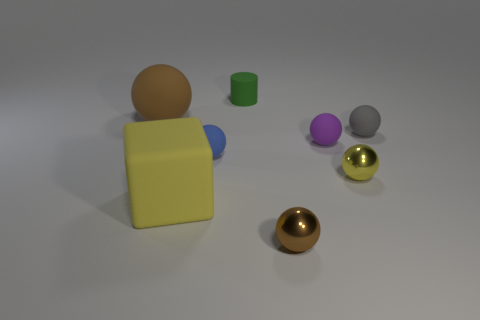Subtract all blue spheres. How many spheres are left? 5 Subtract all blue rubber balls. How many balls are left? 5 Subtract all red spheres. Subtract all red cylinders. How many spheres are left? 6 Add 1 matte objects. How many objects exist? 9 Subtract all cubes. How many objects are left? 7 Subtract all large brown cylinders. Subtract all matte objects. How many objects are left? 2 Add 5 small gray matte spheres. How many small gray matte spheres are left? 6 Add 1 tiny green matte blocks. How many tiny green matte blocks exist? 1 Subtract 0 blue blocks. How many objects are left? 8 